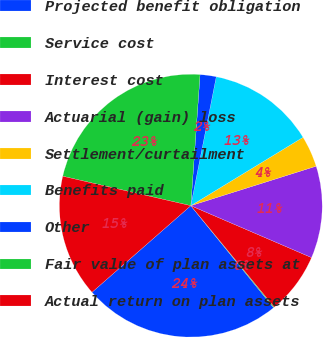<chart> <loc_0><loc_0><loc_500><loc_500><pie_chart><fcel>Projected benefit obligation<fcel>Service cost<fcel>Interest cost<fcel>Actuarial (gain) loss<fcel>Settlement/curtailment<fcel>Benefits paid<fcel>Other<fcel>Fair value of plan assets at<fcel>Actual return on plan assets<nl><fcel>24.39%<fcel>0.11%<fcel>7.58%<fcel>11.32%<fcel>3.85%<fcel>13.19%<fcel>1.98%<fcel>22.52%<fcel>15.05%<nl></chart> 